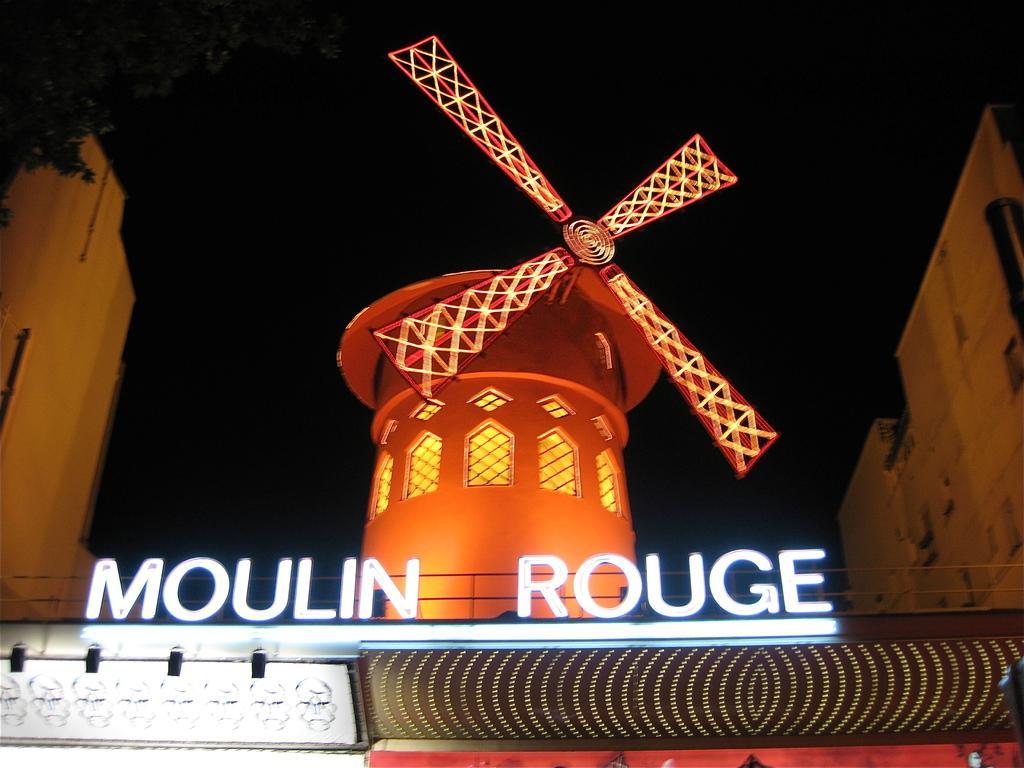In one or two sentences, can you explain what this image depicts? In the center of the image we can see a windmill. In the foreground we can see a sign board. In the background, we can see a group of buildings, trees and sky. 